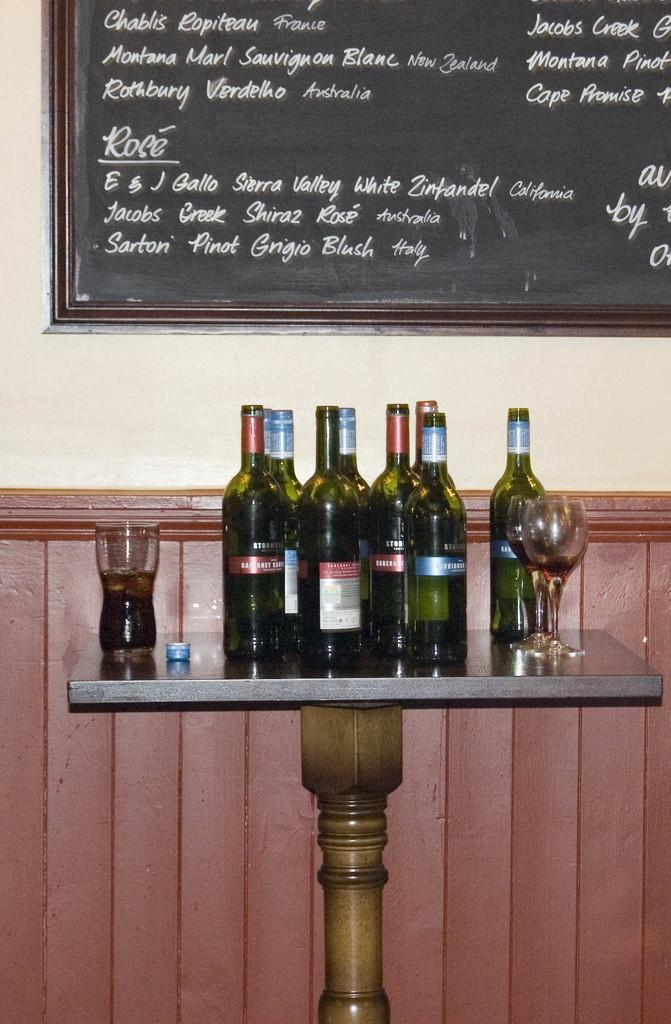<image>
Write a terse but informative summary of the picture. Several bottles of wine and glasses sit on a table below a wine menu on the wall. 